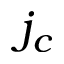Convert formula to latex. <formula><loc_0><loc_0><loc_500><loc_500>j _ { c }</formula> 